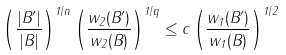<formula> <loc_0><loc_0><loc_500><loc_500>\left ( \frac { | B ^ { \prime } | } { | B | } \right ) ^ { 1 / n } \left ( \frac { w _ { 2 } ( B ^ { \prime } ) } { w _ { 2 } ( B ) } \right ) ^ { 1 / q } \leq c \left ( \frac { w _ { 1 } ( B ^ { \prime } ) } { w _ { 1 } ( B ) } \right ) ^ { 1 / 2 }</formula> 